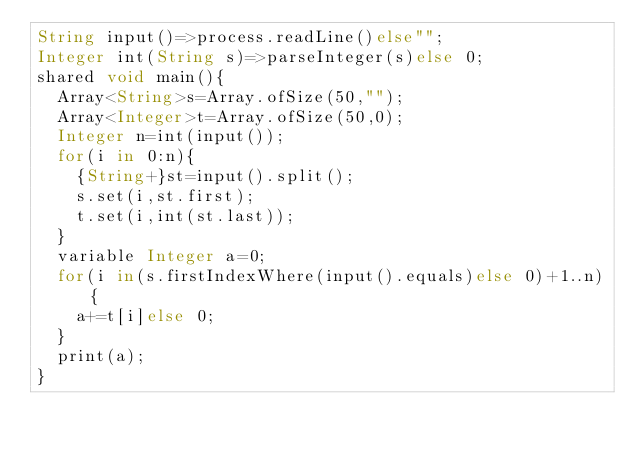<code> <loc_0><loc_0><loc_500><loc_500><_Ceylon_>String input()=>process.readLine()else""; 
Integer int(String s)=>parseInteger(s)else 0;
shared void main(){
  Array<String>s=Array.ofSize(50,"");
  Array<Integer>t=Array.ofSize(50,0);
  Integer n=int(input());
  for(i in 0:n){
    {String+}st=input().split();
    s.set(i,st.first);
    t.set(i,int(st.last));
  }
  variable Integer a=0;
  for(i in(s.firstIndexWhere(input().equals)else 0)+1..n){
    a+=t[i]else 0;
  }
  print(a);
}
</code> 